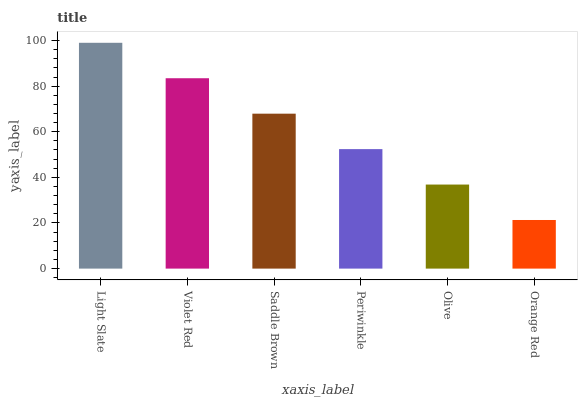Is Orange Red the minimum?
Answer yes or no. Yes. Is Light Slate the maximum?
Answer yes or no. Yes. Is Violet Red the minimum?
Answer yes or no. No. Is Violet Red the maximum?
Answer yes or no. No. Is Light Slate greater than Violet Red?
Answer yes or no. Yes. Is Violet Red less than Light Slate?
Answer yes or no. Yes. Is Violet Red greater than Light Slate?
Answer yes or no. No. Is Light Slate less than Violet Red?
Answer yes or no. No. Is Saddle Brown the high median?
Answer yes or no. Yes. Is Periwinkle the low median?
Answer yes or no. Yes. Is Light Slate the high median?
Answer yes or no. No. Is Saddle Brown the low median?
Answer yes or no. No. 